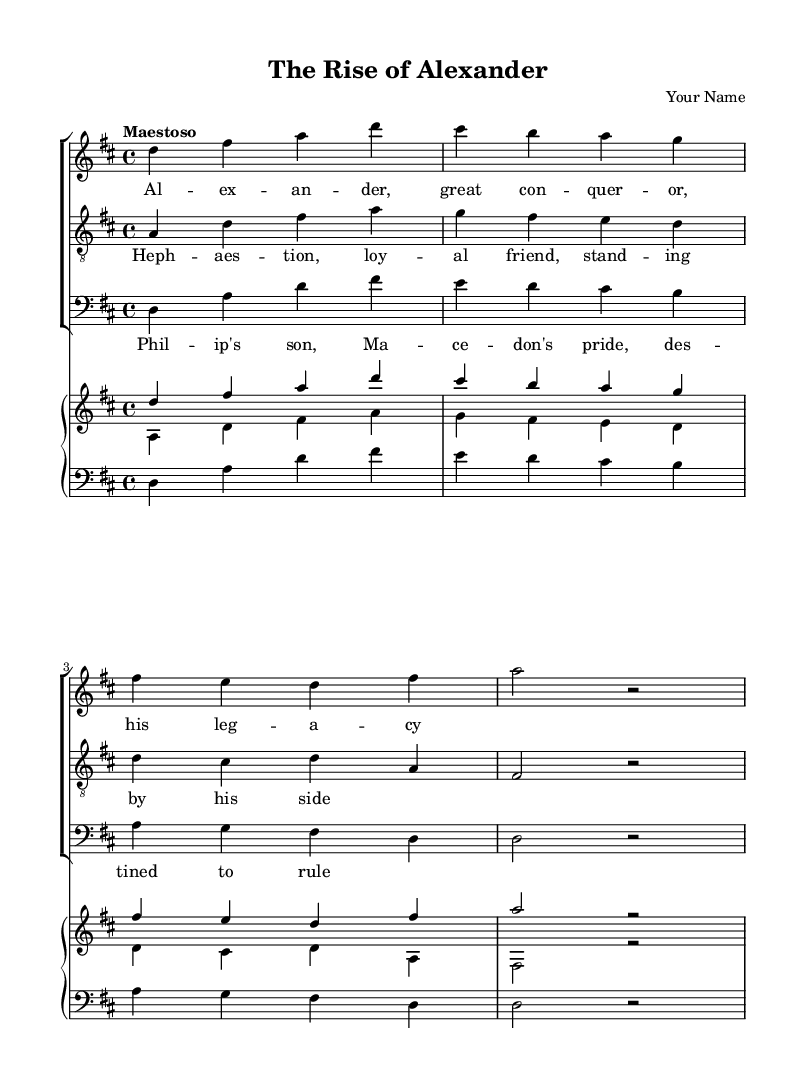What is the key signature of this music? The key signature is D major, as indicated by the two sharps (F# and C#) in the key signature area at the beginning of the score.
Answer: D major What is the time signature of this piece? The time signature is 4/4, shown at the beginning of the score, indicating that there are four beats in each measure and the quarter note receives one beat.
Answer: 4/4 What is the tempo marking for this composition? The tempo marking is "Maestoso," which directs the performer to play the piece in a majestic and stately manner. This is noted at the beginning of the score after the time signature.
Answer: Maestoso Who are the characters represented in the vocal parts? The characters represented are Alexander (soprano), Hephaestion (tenor), and Philip's son (baritone). Each voice has its own lyrics that convey the essence of these historical figures.
Answer: Alexander, Hephaestion, Philip's son How many measures does the soprano part contain in this excerpt? The soprano part contains four measures, which can be counted by noting the bar lines in the part for the soprano voice.
Answer: Four What is the relationship between the tenor and soprano lyrics in this opera? The tenor lyrics express a supportive role, specifically referencing Hephaestion as a loyal friend to Alexander, highlighting the importance of friendship in the narrative of the opera. This shows a dramatic connection between the two characters' stories.
Answer: Supportive friendship 